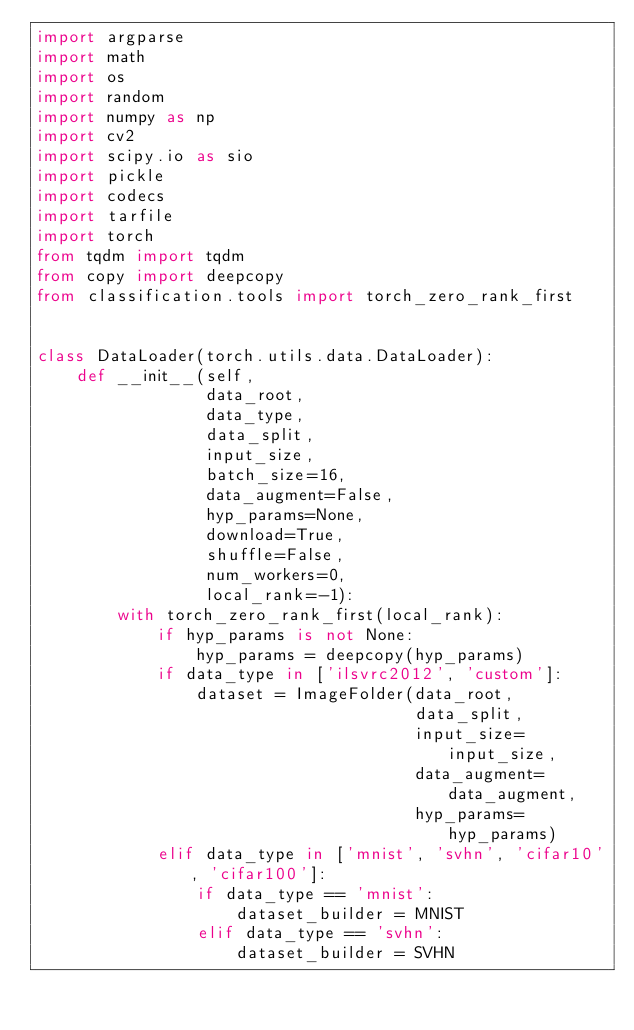<code> <loc_0><loc_0><loc_500><loc_500><_Python_>import argparse
import math
import os
import random
import numpy as np
import cv2
import scipy.io as sio
import pickle
import codecs
import tarfile
import torch
from tqdm import tqdm
from copy import deepcopy
from classification.tools import torch_zero_rank_first


class DataLoader(torch.utils.data.DataLoader):
    def __init__(self,
                 data_root,
                 data_type,
                 data_split,
                 input_size,
                 batch_size=16,
                 data_augment=False,
                 hyp_params=None,
                 download=True,
                 shuffle=False,
                 num_workers=0,
                 local_rank=-1):
        with torch_zero_rank_first(local_rank):
            if hyp_params is not None:
                hyp_params = deepcopy(hyp_params)
            if data_type in ['ilsvrc2012', 'custom']:
                dataset = ImageFolder(data_root,
                                      data_split,
                                      input_size=input_size,
                                      data_augment=data_augment,
                                      hyp_params=hyp_params)
            elif data_type in ['mnist', 'svhn', 'cifar10', 'cifar100']:
                if data_type == 'mnist':
                    dataset_builder = MNIST
                elif data_type == 'svhn':
                    dataset_builder = SVHN</code> 